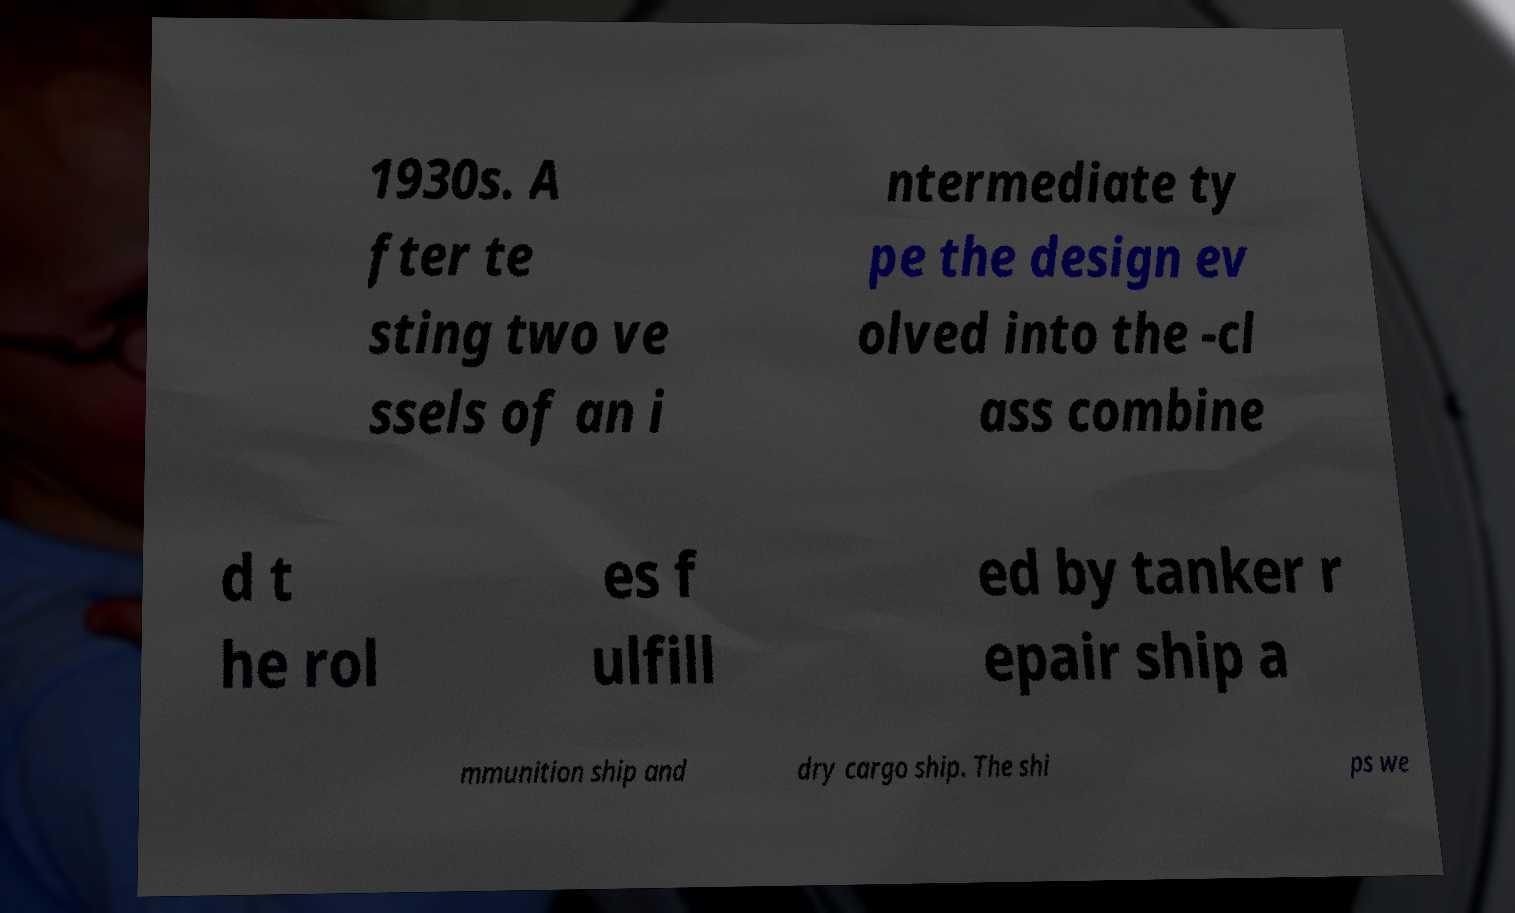Can you accurately transcribe the text from the provided image for me? 1930s. A fter te sting two ve ssels of an i ntermediate ty pe the design ev olved into the -cl ass combine d t he rol es f ulfill ed by tanker r epair ship a mmunition ship and dry cargo ship. The shi ps we 